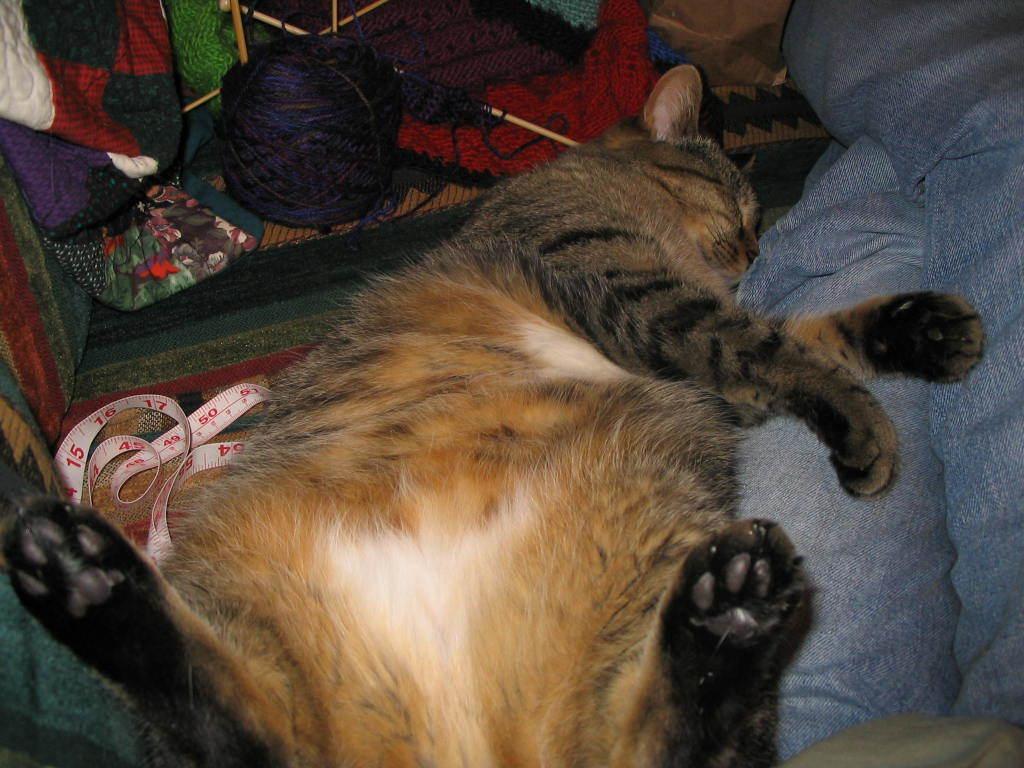Describe this image in one or two sentences. In this picture, there is a cat and beside the cat, we see a measuring tape and a blue color bag. On the right corner of the picture, we see the legs of the human wearing a grey color pant. In the background, we see a red color cloth. This picture is clicked inside the room. 